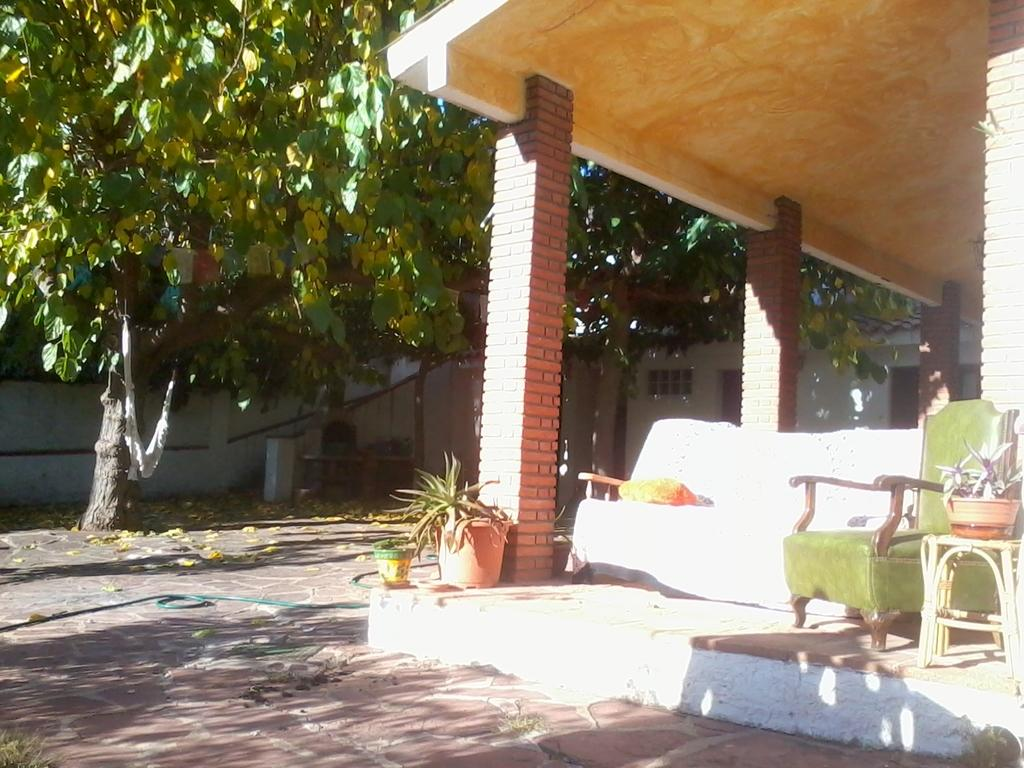What is located in front of a wall in the image? There is a tree in front of a wall in the image. What type of furniture can be seen in the image? There is a sofa, a chair, and a stool in the image. Where are the pieces of furniture located? The furniture is under a building in the image. What can be seen in front of a house in the image? There are two plants in front of a house in the image. How many houses are depicted in the image? There is no mention of houses in the image; it features a tree in front of a wall, furniture under a building, and two plants in front of a house. What type of bean is present in the image? There is no bean present in the image. 